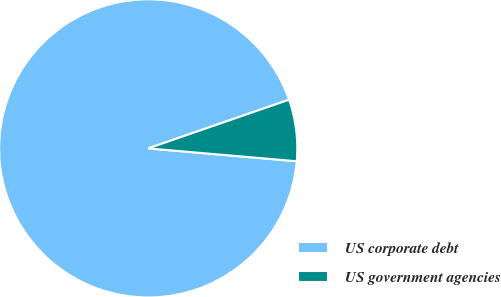<chart> <loc_0><loc_0><loc_500><loc_500><pie_chart><fcel>US corporate debt<fcel>US government agencies<nl><fcel>93.33%<fcel>6.67%<nl></chart> 